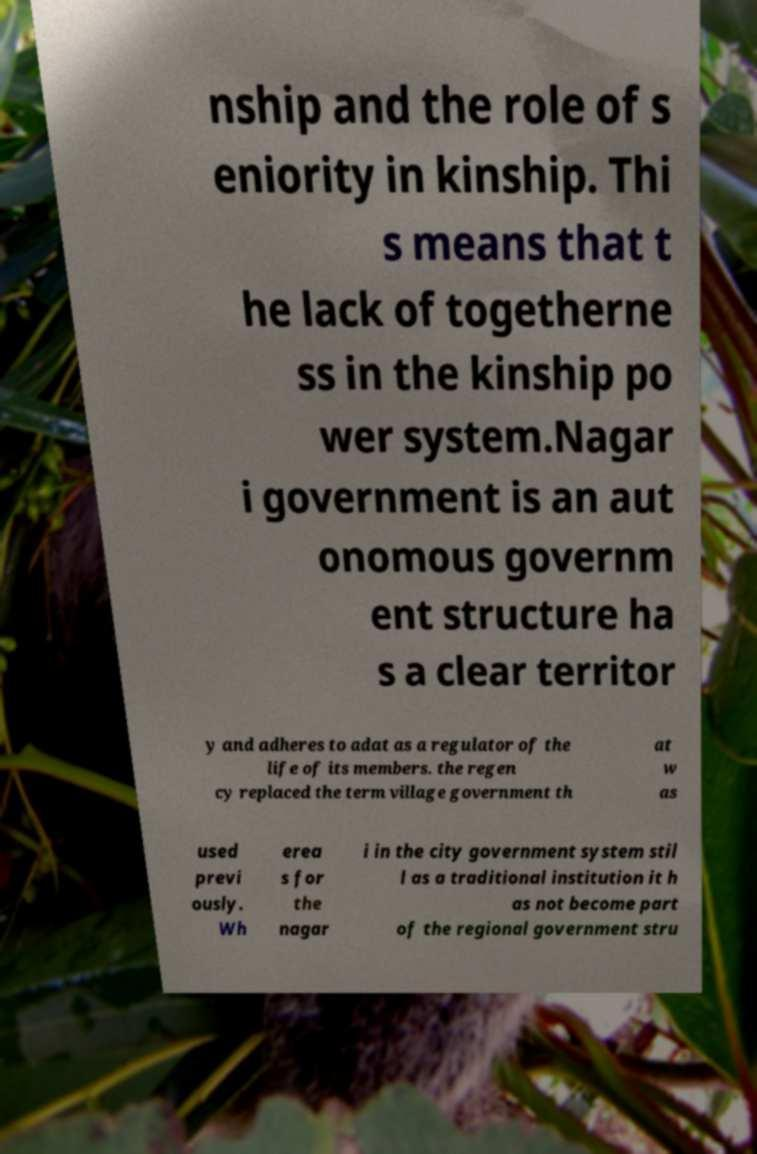For documentation purposes, I need the text within this image transcribed. Could you provide that? nship and the role of s eniority in kinship. Thi s means that t he lack of togetherne ss in the kinship po wer system.Nagar i government is an aut onomous governm ent structure ha s a clear territor y and adheres to adat as a regulator of the life of its members. the regen cy replaced the term village government th at w as used previ ously. Wh erea s for the nagar i in the city government system stil l as a traditional institution it h as not become part of the regional government stru 